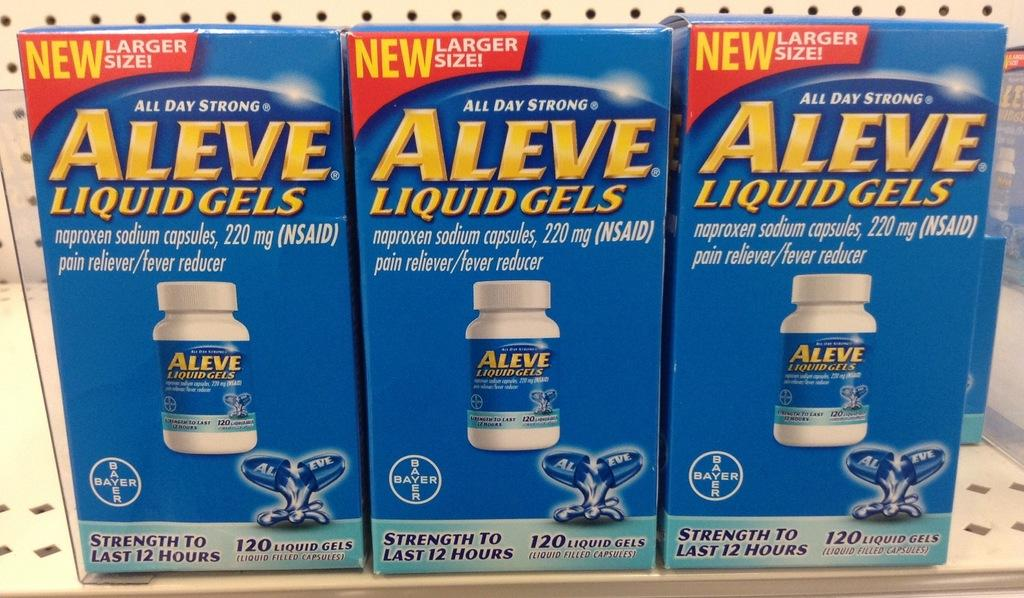<image>
Give a short and clear explanation of the subsequent image. Three boxes of liquid gels tell a potential buyer that they are new. 